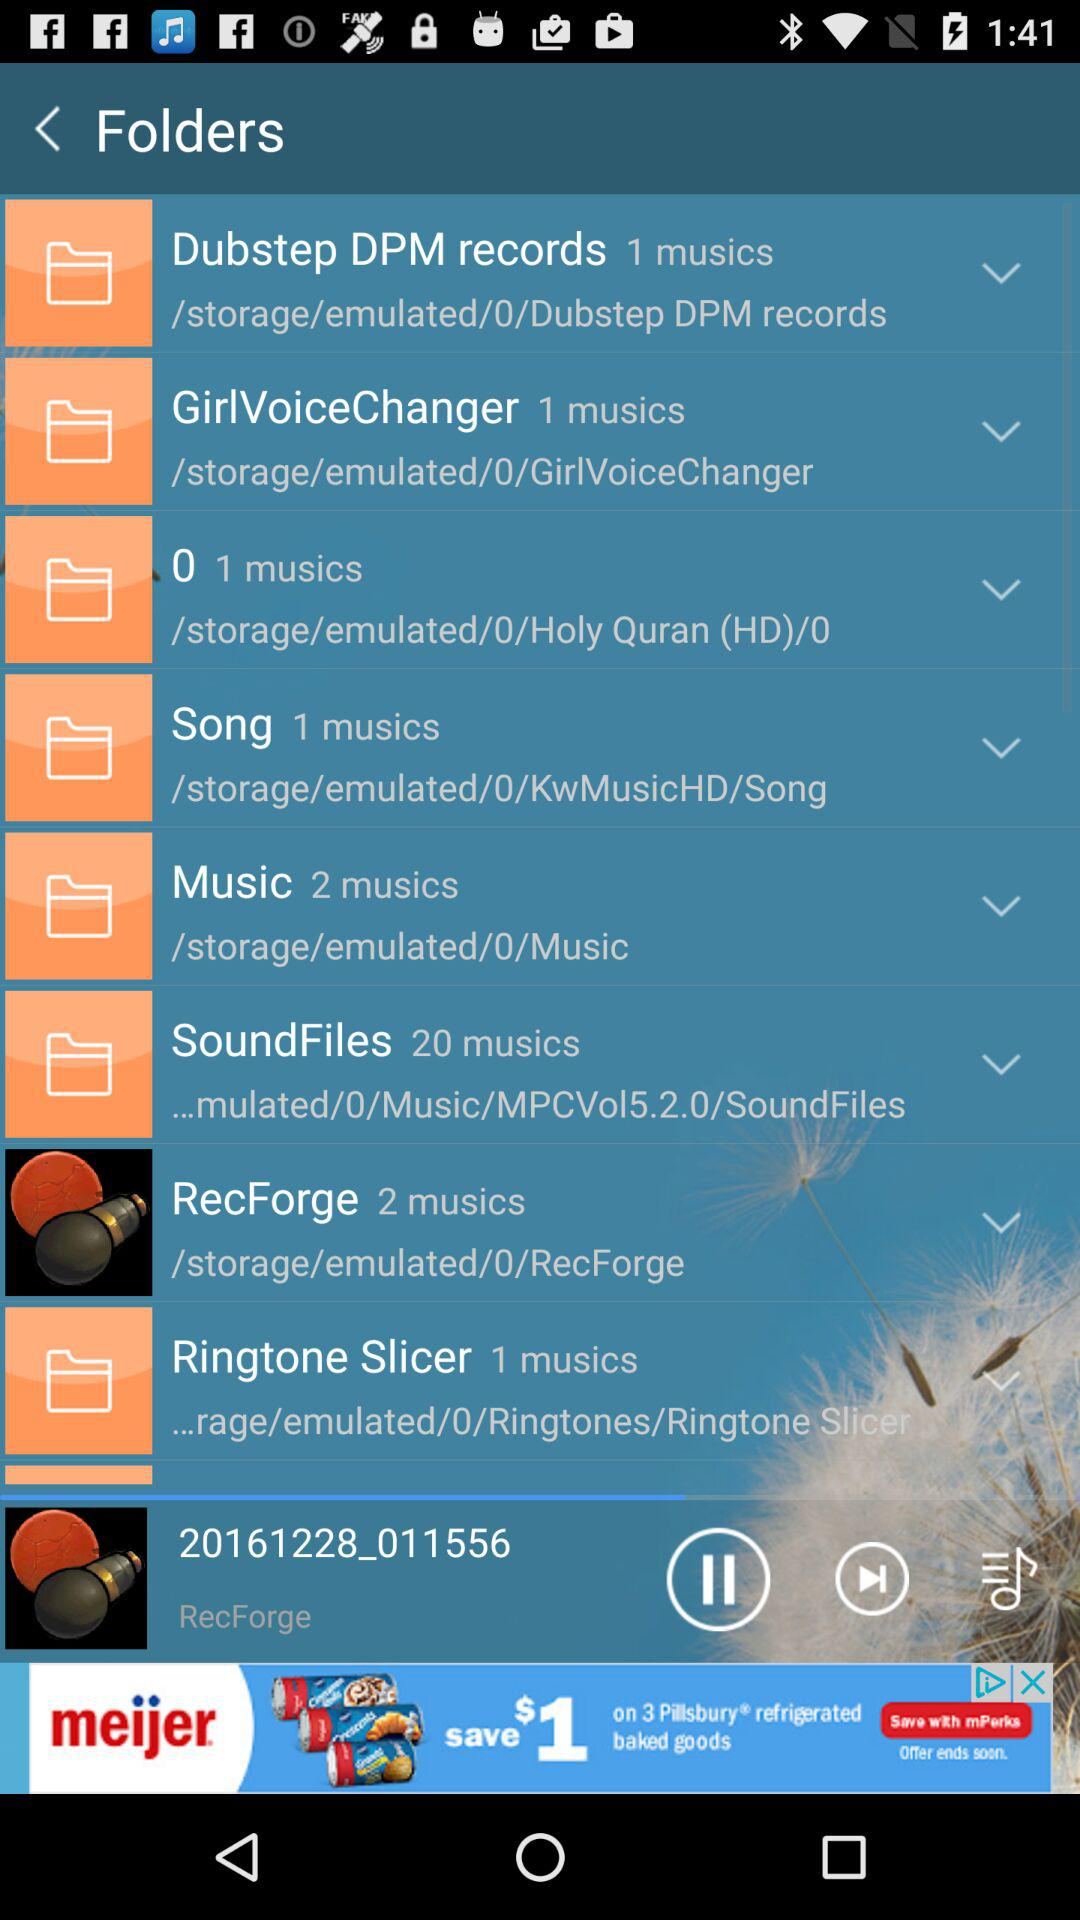What is the number of music in the "Music" folder? The number of music in the "Music" folder is 2. 